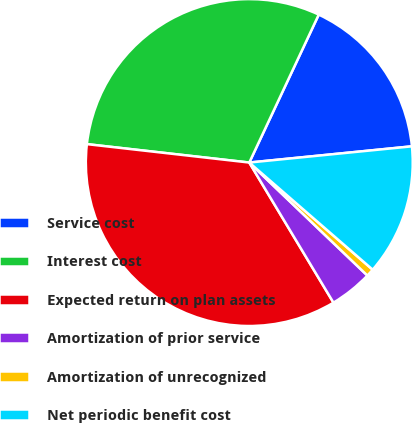<chart> <loc_0><loc_0><loc_500><loc_500><pie_chart><fcel>Service cost<fcel>Interest cost<fcel>Expected return on plan assets<fcel>Amortization of prior service<fcel>Amortization of unrecognized<fcel>Net periodic benefit cost<nl><fcel>16.43%<fcel>30.19%<fcel>35.41%<fcel>4.24%<fcel>0.77%<fcel>12.96%<nl></chart> 